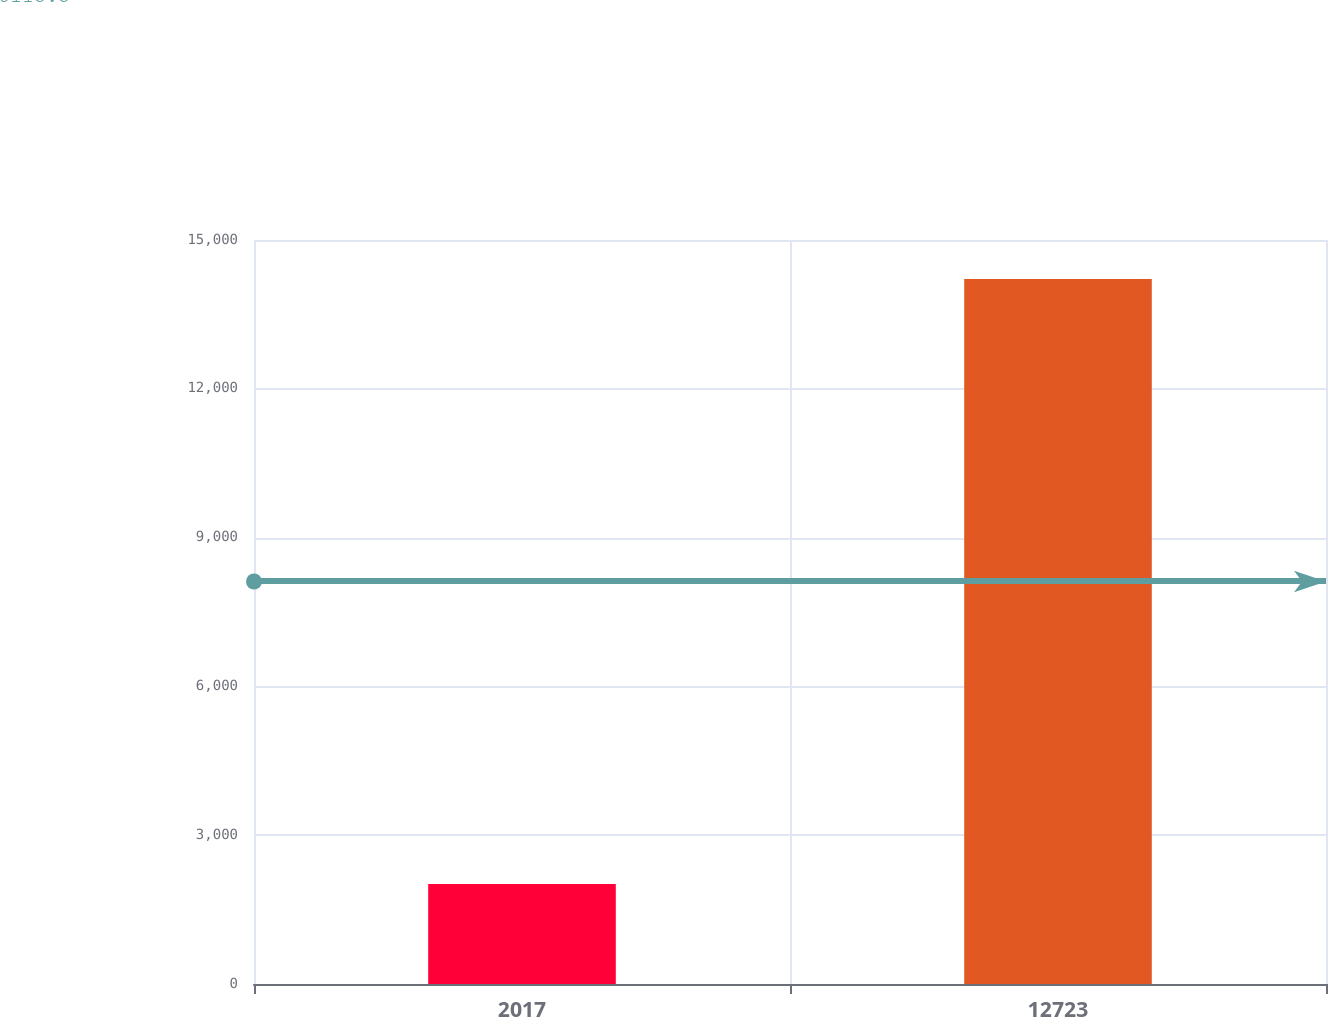Convert chart. <chart><loc_0><loc_0><loc_500><loc_500><bar_chart><fcel>2017<fcel>12723<nl><fcel>2016<fcel>14215<nl></chart> 